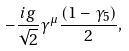Convert formula to latex. <formula><loc_0><loc_0><loc_500><loc_500>- \frac { i g } { \sqrt { 2 } } \gamma ^ { \mu } \frac { ( 1 - \gamma _ { 5 } ) } { 2 } ,</formula> 